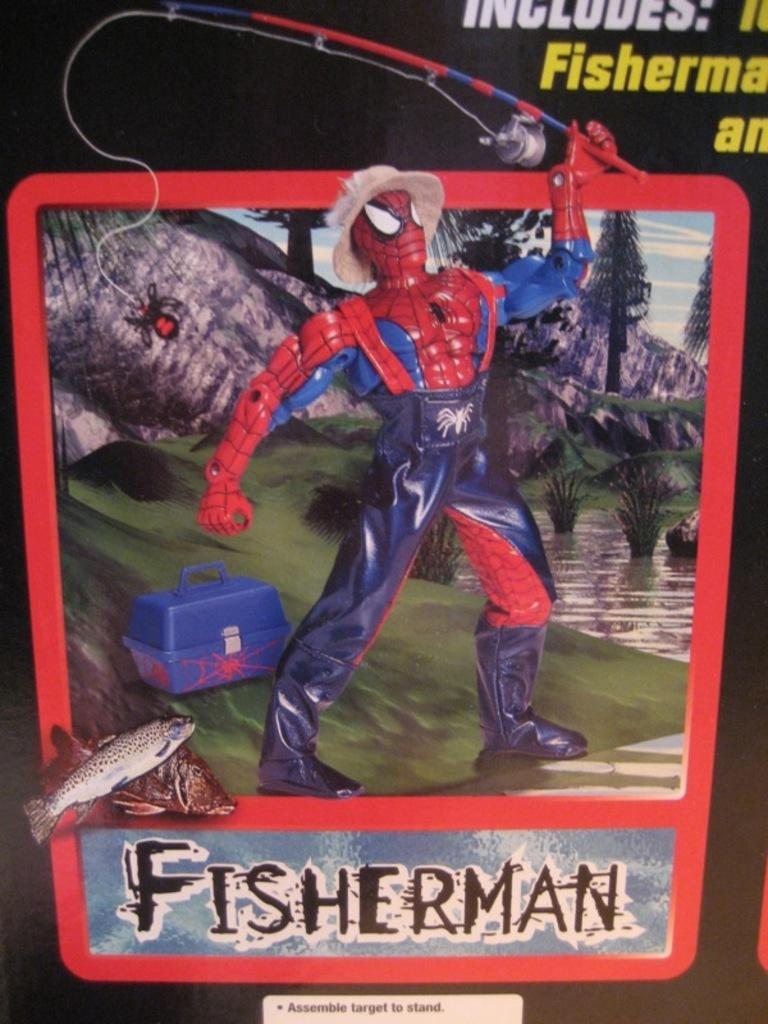What is the main feature of the image? There is a banner in the image. What images can be seen on the banner? The banner contains an image of a man, a suitcase, water, trees, and the sky. Is there any text on the banner? Yes, there is text written on the banner. What type of cheese is being used to create the banner in the image? There is no cheese present in the image; it is a banner made of fabric or paper with images and text. 